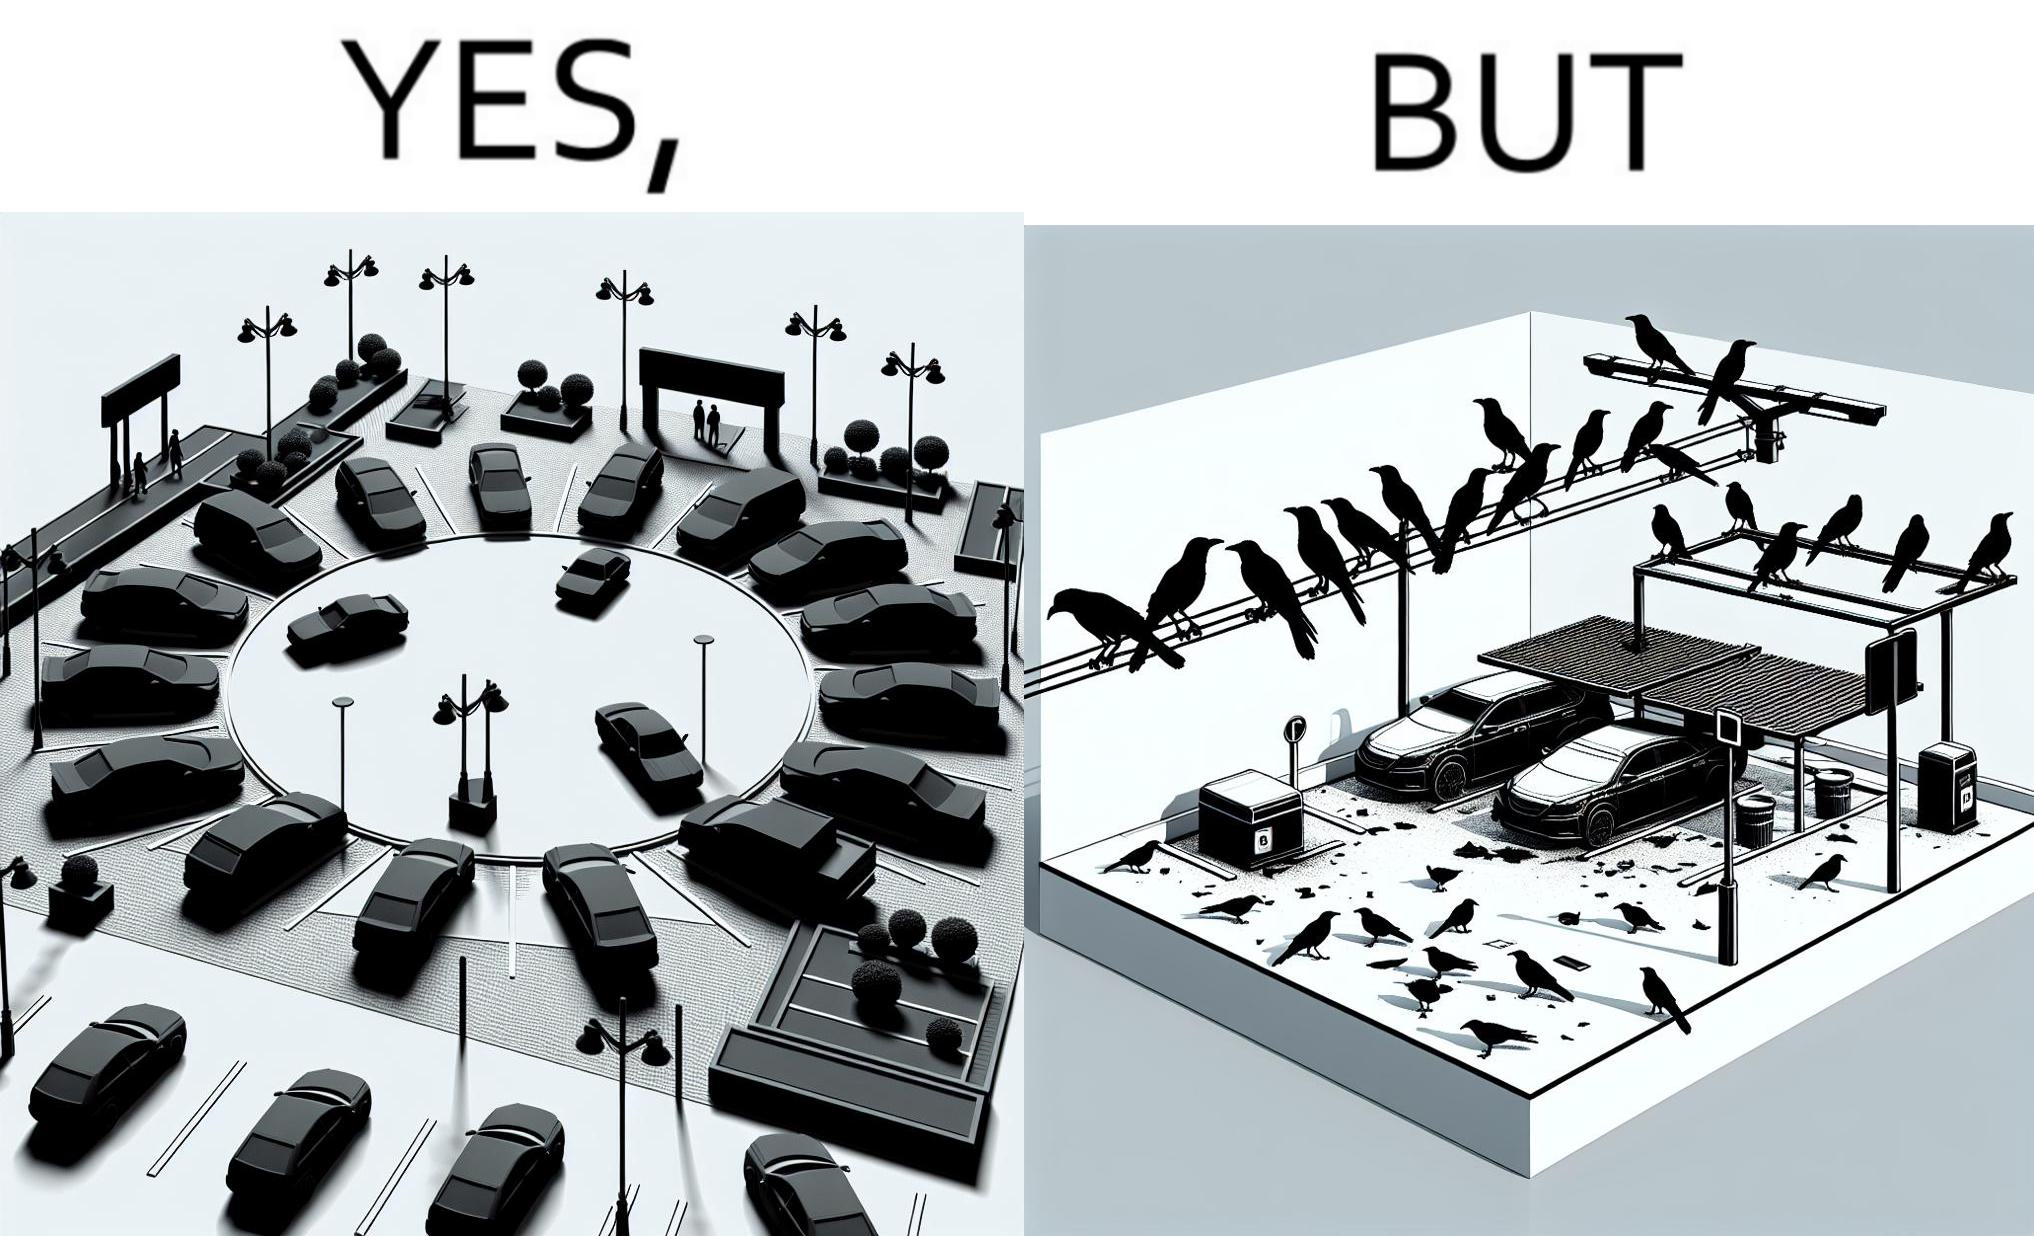Why is this image considered satirical? The image is ironical such that although there is a place for parking but that place is not suitable because if we place our car there then our car will become dirty from top due to crow beet. 